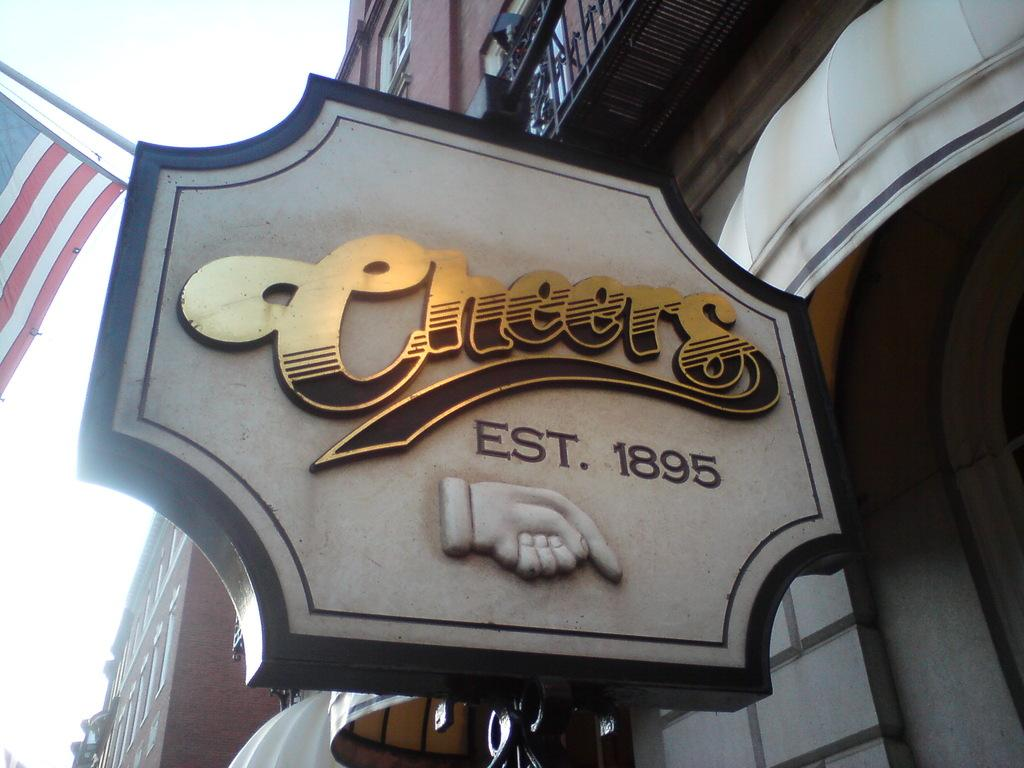What is the main object in the foreground of the image? There is a name board in the image. What can be seen in the background of the image? There are buildings behind the name board. Where is the flag located in the image? The flag is on the left side of the image. What is visible in the sky in the image? The sky is visible in the image. How does the sock contribute to the thrill of the beginner in the image? There is no sock or beginner present in the image, so this question cannot be answered. 